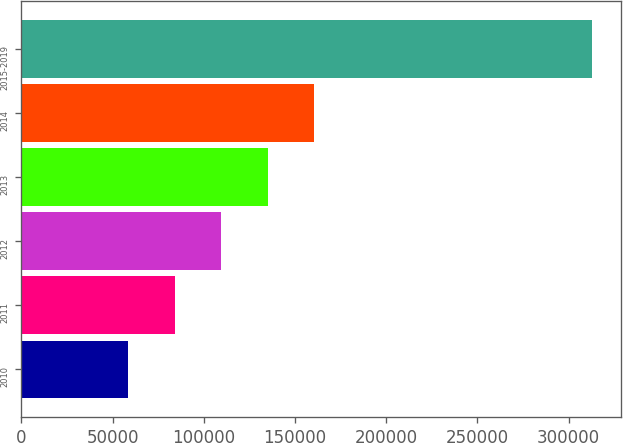<chart> <loc_0><loc_0><loc_500><loc_500><bar_chart><fcel>2010<fcel>2011<fcel>2012<fcel>2013<fcel>2014<fcel>2015-2019<nl><fcel>58738<fcel>84168.2<fcel>109598<fcel>135029<fcel>160459<fcel>313040<nl></chart> 